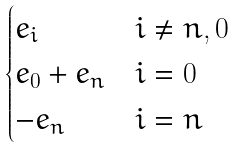Convert formula to latex. <formula><loc_0><loc_0><loc_500><loc_500>\begin{cases} e _ { i } & i \ne n , 0 \\ e _ { 0 } + e _ { n } & i = 0 \\ - e _ { n } & i = n \\ \end{cases}</formula> 